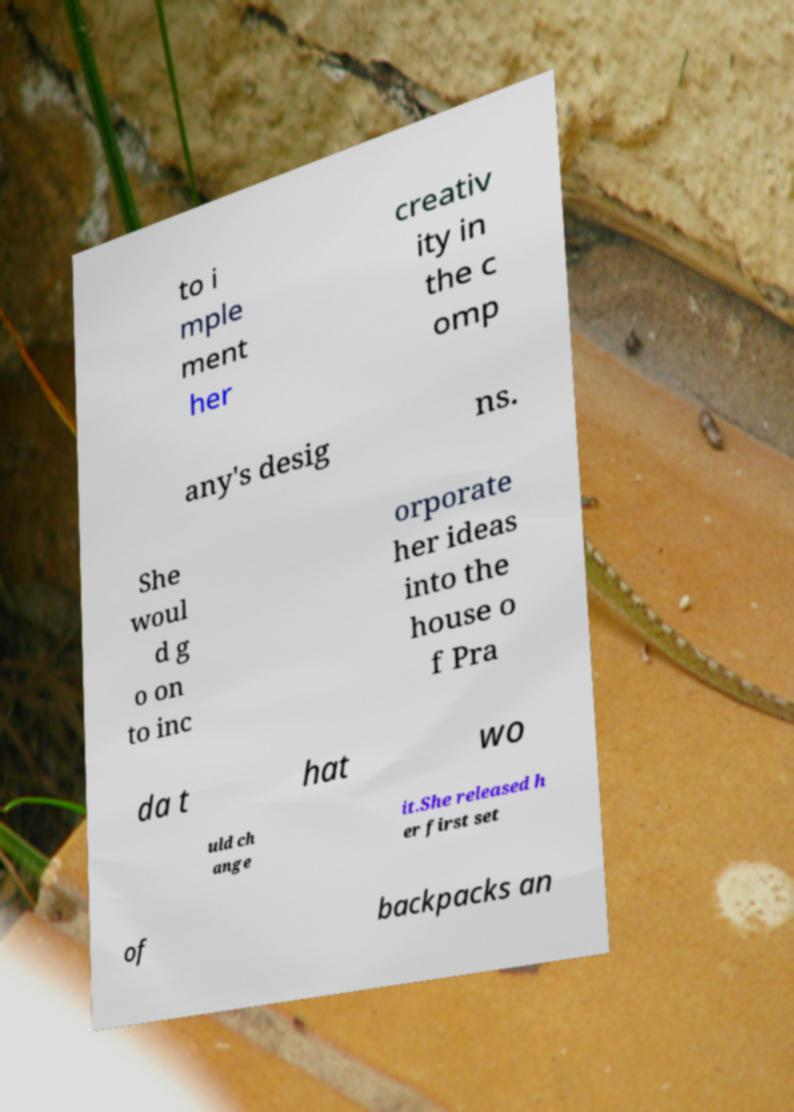For documentation purposes, I need the text within this image transcribed. Could you provide that? to i mple ment her creativ ity in the c omp any's desig ns. She woul d g o on to inc orporate her ideas into the house o f Pra da t hat wo uld ch ange it.She released h er first set of backpacks an 